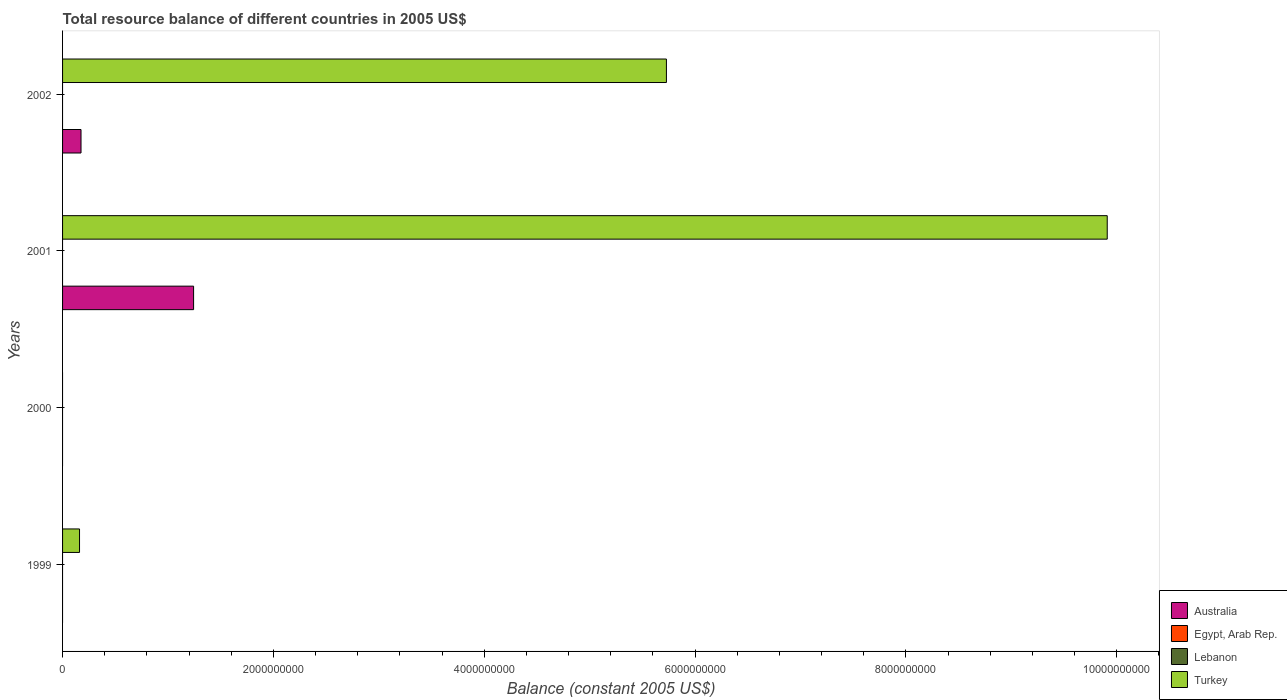Are the number of bars per tick equal to the number of legend labels?
Your response must be concise. No. Are the number of bars on each tick of the Y-axis equal?
Keep it short and to the point. No. How many bars are there on the 2nd tick from the top?
Provide a short and direct response. 2. Across all years, what is the maximum total resource balance in Turkey?
Keep it short and to the point. 9.91e+09. In which year was the total resource balance in Australia maximum?
Offer a terse response. 2001. What is the difference between the total resource balance in Lebanon in 1999 and the total resource balance in Australia in 2001?
Provide a succinct answer. -1.24e+09. What is the average total resource balance in Turkey per year?
Your answer should be compact. 3.95e+09. What is the difference between the highest and the second highest total resource balance in Turkey?
Give a very brief answer. 4.18e+09. What is the difference between the highest and the lowest total resource balance in Australia?
Offer a very short reply. 1.24e+09. Is it the case that in every year, the sum of the total resource balance in Lebanon and total resource balance in Turkey is greater than the total resource balance in Egypt, Arab Rep.?
Keep it short and to the point. No. How many bars are there?
Your answer should be compact. 5. Does the graph contain any zero values?
Keep it short and to the point. Yes. Does the graph contain grids?
Your answer should be very brief. No. How many legend labels are there?
Make the answer very short. 4. What is the title of the graph?
Your response must be concise. Total resource balance of different countries in 2005 US$. What is the label or title of the X-axis?
Keep it short and to the point. Balance (constant 2005 US$). What is the label or title of the Y-axis?
Ensure brevity in your answer.  Years. What is the Balance (constant 2005 US$) of Turkey in 1999?
Your answer should be very brief. 1.61e+08. What is the Balance (constant 2005 US$) in Australia in 2000?
Your answer should be very brief. 0. What is the Balance (constant 2005 US$) of Egypt, Arab Rep. in 2000?
Provide a succinct answer. 0. What is the Balance (constant 2005 US$) in Australia in 2001?
Keep it short and to the point. 1.24e+09. What is the Balance (constant 2005 US$) in Turkey in 2001?
Offer a terse response. 9.91e+09. What is the Balance (constant 2005 US$) in Australia in 2002?
Your answer should be compact. 1.75e+08. What is the Balance (constant 2005 US$) of Lebanon in 2002?
Make the answer very short. 0. What is the Balance (constant 2005 US$) in Turkey in 2002?
Your response must be concise. 5.73e+09. Across all years, what is the maximum Balance (constant 2005 US$) of Australia?
Provide a succinct answer. 1.24e+09. Across all years, what is the maximum Balance (constant 2005 US$) of Turkey?
Keep it short and to the point. 9.91e+09. Across all years, what is the minimum Balance (constant 2005 US$) in Australia?
Ensure brevity in your answer.  0. What is the total Balance (constant 2005 US$) of Australia in the graph?
Offer a very short reply. 1.42e+09. What is the total Balance (constant 2005 US$) in Turkey in the graph?
Ensure brevity in your answer.  1.58e+1. What is the difference between the Balance (constant 2005 US$) in Turkey in 1999 and that in 2001?
Keep it short and to the point. -9.75e+09. What is the difference between the Balance (constant 2005 US$) of Turkey in 1999 and that in 2002?
Your answer should be compact. -5.57e+09. What is the difference between the Balance (constant 2005 US$) of Australia in 2001 and that in 2002?
Offer a terse response. 1.07e+09. What is the difference between the Balance (constant 2005 US$) in Turkey in 2001 and that in 2002?
Your response must be concise. 4.18e+09. What is the difference between the Balance (constant 2005 US$) in Australia in 2001 and the Balance (constant 2005 US$) in Turkey in 2002?
Give a very brief answer. -4.49e+09. What is the average Balance (constant 2005 US$) in Australia per year?
Provide a short and direct response. 3.54e+08. What is the average Balance (constant 2005 US$) of Lebanon per year?
Make the answer very short. 0. What is the average Balance (constant 2005 US$) of Turkey per year?
Offer a terse response. 3.95e+09. In the year 2001, what is the difference between the Balance (constant 2005 US$) in Australia and Balance (constant 2005 US$) in Turkey?
Your answer should be compact. -8.67e+09. In the year 2002, what is the difference between the Balance (constant 2005 US$) of Australia and Balance (constant 2005 US$) of Turkey?
Make the answer very short. -5.55e+09. What is the ratio of the Balance (constant 2005 US$) of Turkey in 1999 to that in 2001?
Provide a short and direct response. 0.02. What is the ratio of the Balance (constant 2005 US$) of Turkey in 1999 to that in 2002?
Give a very brief answer. 0.03. What is the ratio of the Balance (constant 2005 US$) in Australia in 2001 to that in 2002?
Offer a very short reply. 7.1. What is the ratio of the Balance (constant 2005 US$) of Turkey in 2001 to that in 2002?
Your response must be concise. 1.73. What is the difference between the highest and the second highest Balance (constant 2005 US$) in Turkey?
Offer a terse response. 4.18e+09. What is the difference between the highest and the lowest Balance (constant 2005 US$) in Australia?
Give a very brief answer. 1.24e+09. What is the difference between the highest and the lowest Balance (constant 2005 US$) in Turkey?
Your response must be concise. 9.91e+09. 